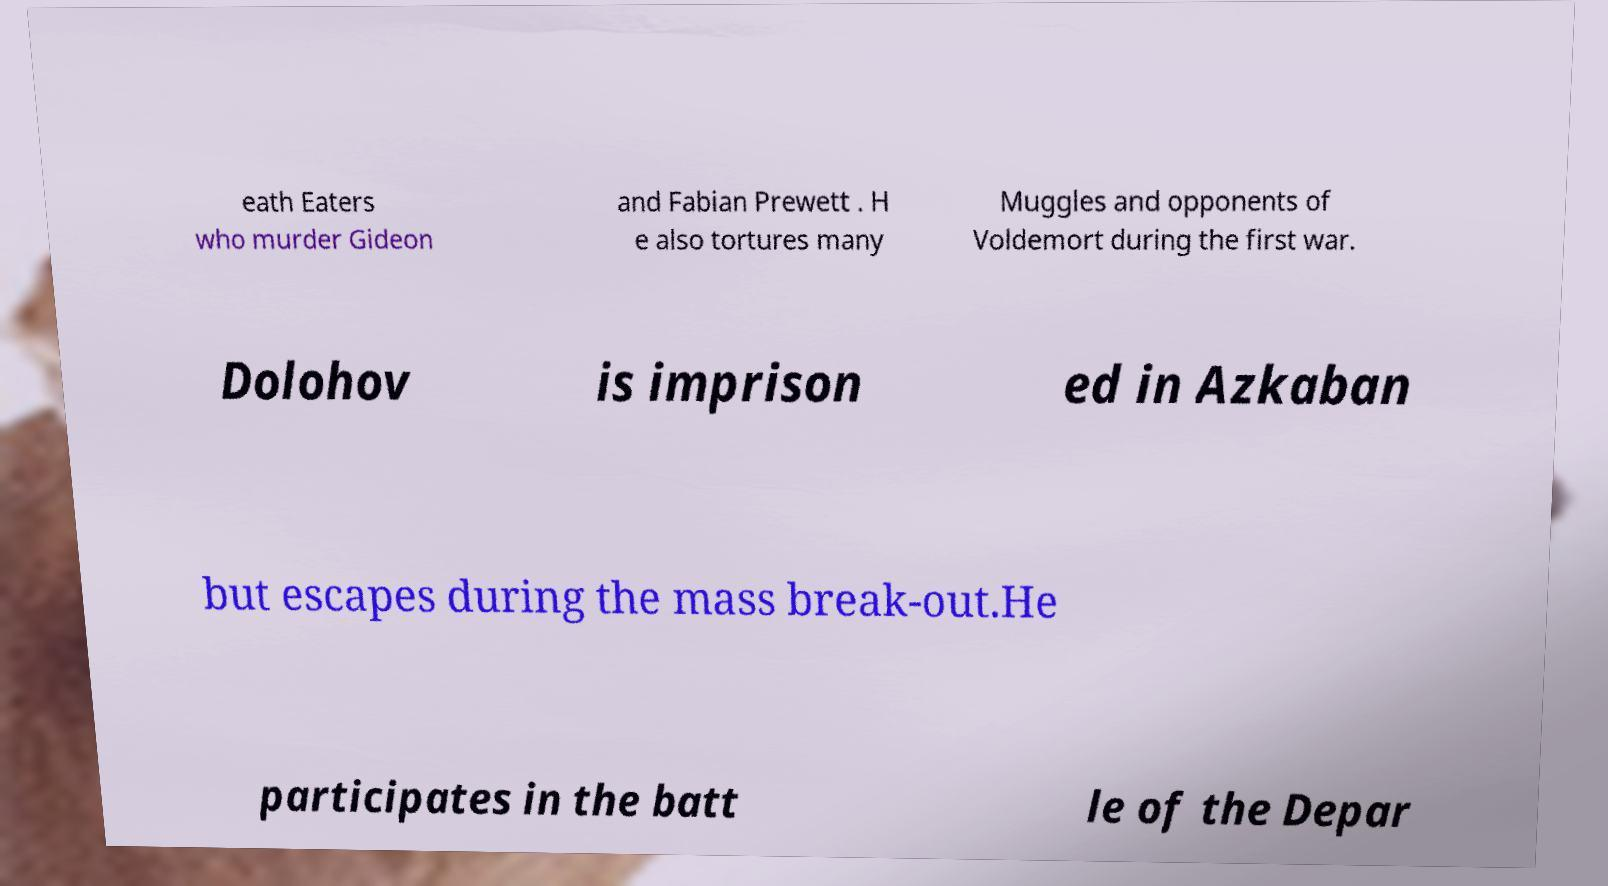Could you extract and type out the text from this image? eath Eaters who murder Gideon and Fabian Prewett . H e also tortures many Muggles and opponents of Voldemort during the first war. Dolohov is imprison ed in Azkaban but escapes during the mass break-out.He participates in the batt le of the Depar 